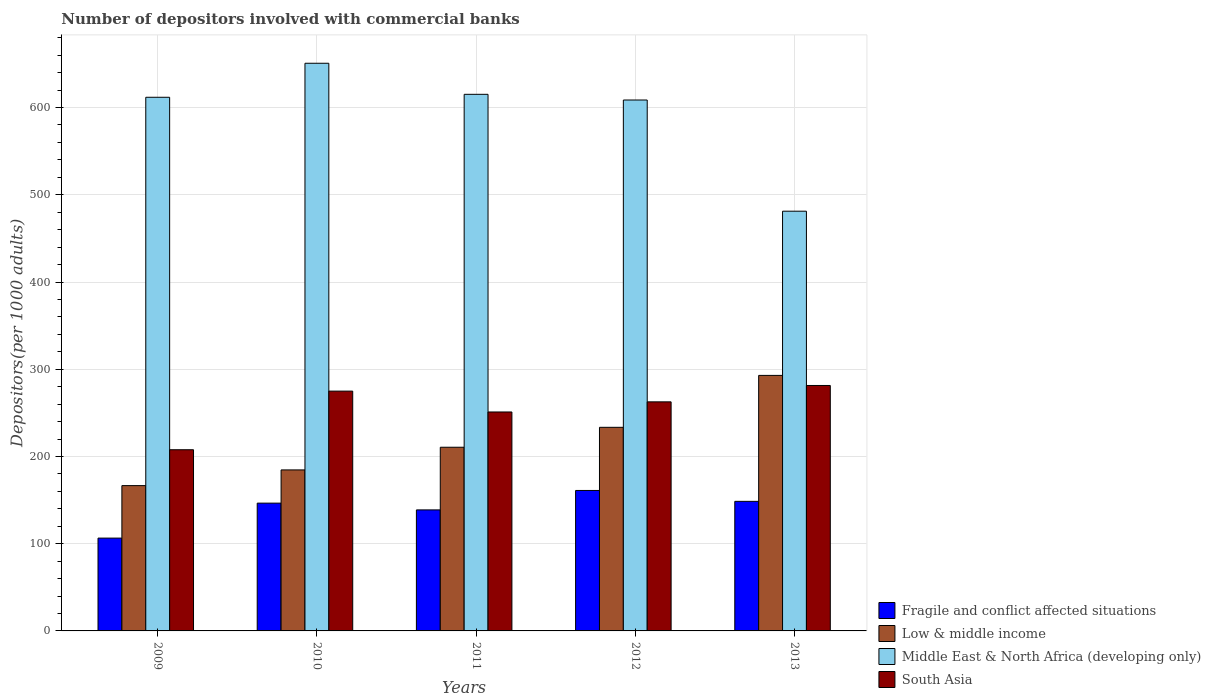How many groups of bars are there?
Offer a terse response. 5. Are the number of bars per tick equal to the number of legend labels?
Offer a very short reply. Yes. How many bars are there on the 2nd tick from the left?
Offer a terse response. 4. What is the label of the 1st group of bars from the left?
Give a very brief answer. 2009. In how many cases, is the number of bars for a given year not equal to the number of legend labels?
Give a very brief answer. 0. What is the number of depositors involved with commercial banks in Fragile and conflict affected situations in 2011?
Offer a terse response. 138.74. Across all years, what is the maximum number of depositors involved with commercial banks in South Asia?
Offer a terse response. 281.38. Across all years, what is the minimum number of depositors involved with commercial banks in Middle East & North Africa (developing only)?
Offer a terse response. 481.17. In which year was the number of depositors involved with commercial banks in South Asia minimum?
Provide a short and direct response. 2009. What is the total number of depositors involved with commercial banks in Low & middle income in the graph?
Your response must be concise. 1088.05. What is the difference between the number of depositors involved with commercial banks in Middle East & North Africa (developing only) in 2011 and that in 2013?
Offer a terse response. 133.99. What is the difference between the number of depositors involved with commercial banks in South Asia in 2010 and the number of depositors involved with commercial banks in Low & middle income in 2009?
Your answer should be compact. 108.34. What is the average number of depositors involved with commercial banks in Fragile and conflict affected situations per year?
Provide a short and direct response. 140.24. In the year 2009, what is the difference between the number of depositors involved with commercial banks in Fragile and conflict affected situations and number of depositors involved with commercial banks in Low & middle income?
Make the answer very short. -60.16. In how many years, is the number of depositors involved with commercial banks in South Asia greater than 560?
Provide a succinct answer. 0. What is the ratio of the number of depositors involved with commercial banks in Low & middle income in 2009 to that in 2012?
Your answer should be compact. 0.71. What is the difference between the highest and the second highest number of depositors involved with commercial banks in Low & middle income?
Your answer should be very brief. 59.52. What is the difference between the highest and the lowest number of depositors involved with commercial banks in Low & middle income?
Provide a succinct answer. 126.36. What does the 1st bar from the right in 2012 represents?
Provide a short and direct response. South Asia. Is it the case that in every year, the sum of the number of depositors involved with commercial banks in Low & middle income and number of depositors involved with commercial banks in South Asia is greater than the number of depositors involved with commercial banks in Middle East & North Africa (developing only)?
Your answer should be compact. No. Are all the bars in the graph horizontal?
Provide a succinct answer. No. What is the difference between two consecutive major ticks on the Y-axis?
Your answer should be compact. 100. Does the graph contain any zero values?
Your answer should be very brief. No. Where does the legend appear in the graph?
Ensure brevity in your answer.  Bottom right. How many legend labels are there?
Keep it short and to the point. 4. How are the legend labels stacked?
Offer a very short reply. Vertical. What is the title of the graph?
Ensure brevity in your answer.  Number of depositors involved with commercial banks. Does "Nigeria" appear as one of the legend labels in the graph?
Provide a succinct answer. No. What is the label or title of the X-axis?
Your answer should be compact. Years. What is the label or title of the Y-axis?
Offer a terse response. Depositors(per 1000 adults). What is the Depositors(per 1000 adults) of Fragile and conflict affected situations in 2009?
Your answer should be compact. 106.41. What is the Depositors(per 1000 adults) in Low & middle income in 2009?
Your response must be concise. 166.57. What is the Depositors(per 1000 adults) of Middle East & North Africa (developing only) in 2009?
Offer a terse response. 611.77. What is the Depositors(per 1000 adults) of South Asia in 2009?
Keep it short and to the point. 207.71. What is the Depositors(per 1000 adults) of Fragile and conflict affected situations in 2010?
Give a very brief answer. 146.5. What is the Depositors(per 1000 adults) of Low & middle income in 2010?
Offer a terse response. 184.58. What is the Depositors(per 1000 adults) of Middle East & North Africa (developing only) in 2010?
Provide a short and direct response. 650.77. What is the Depositors(per 1000 adults) of South Asia in 2010?
Ensure brevity in your answer.  274.9. What is the Depositors(per 1000 adults) in Fragile and conflict affected situations in 2011?
Your answer should be very brief. 138.74. What is the Depositors(per 1000 adults) in Low & middle income in 2011?
Your answer should be compact. 210.56. What is the Depositors(per 1000 adults) of Middle East & North Africa (developing only) in 2011?
Your response must be concise. 615.16. What is the Depositors(per 1000 adults) in South Asia in 2011?
Make the answer very short. 250.99. What is the Depositors(per 1000 adults) of Fragile and conflict affected situations in 2012?
Offer a very short reply. 161.02. What is the Depositors(per 1000 adults) of Low & middle income in 2012?
Provide a short and direct response. 233.41. What is the Depositors(per 1000 adults) of Middle East & North Africa (developing only) in 2012?
Ensure brevity in your answer.  608.64. What is the Depositors(per 1000 adults) of South Asia in 2012?
Give a very brief answer. 262.6. What is the Depositors(per 1000 adults) in Fragile and conflict affected situations in 2013?
Make the answer very short. 148.53. What is the Depositors(per 1000 adults) of Low & middle income in 2013?
Your answer should be compact. 292.93. What is the Depositors(per 1000 adults) in Middle East & North Africa (developing only) in 2013?
Keep it short and to the point. 481.17. What is the Depositors(per 1000 adults) in South Asia in 2013?
Your answer should be compact. 281.38. Across all years, what is the maximum Depositors(per 1000 adults) of Fragile and conflict affected situations?
Your response must be concise. 161.02. Across all years, what is the maximum Depositors(per 1000 adults) in Low & middle income?
Provide a short and direct response. 292.93. Across all years, what is the maximum Depositors(per 1000 adults) in Middle East & North Africa (developing only)?
Provide a short and direct response. 650.77. Across all years, what is the maximum Depositors(per 1000 adults) of South Asia?
Give a very brief answer. 281.38. Across all years, what is the minimum Depositors(per 1000 adults) of Fragile and conflict affected situations?
Provide a short and direct response. 106.41. Across all years, what is the minimum Depositors(per 1000 adults) of Low & middle income?
Give a very brief answer. 166.57. Across all years, what is the minimum Depositors(per 1000 adults) in Middle East & North Africa (developing only)?
Ensure brevity in your answer.  481.17. Across all years, what is the minimum Depositors(per 1000 adults) in South Asia?
Keep it short and to the point. 207.71. What is the total Depositors(per 1000 adults) in Fragile and conflict affected situations in the graph?
Provide a succinct answer. 701.2. What is the total Depositors(per 1000 adults) of Low & middle income in the graph?
Your response must be concise. 1088.05. What is the total Depositors(per 1000 adults) of Middle East & North Africa (developing only) in the graph?
Keep it short and to the point. 2967.5. What is the total Depositors(per 1000 adults) of South Asia in the graph?
Make the answer very short. 1277.59. What is the difference between the Depositors(per 1000 adults) in Fragile and conflict affected situations in 2009 and that in 2010?
Your response must be concise. -40.09. What is the difference between the Depositors(per 1000 adults) of Low & middle income in 2009 and that in 2010?
Give a very brief answer. -18.01. What is the difference between the Depositors(per 1000 adults) in Middle East & North Africa (developing only) in 2009 and that in 2010?
Offer a very short reply. -39. What is the difference between the Depositors(per 1000 adults) of South Asia in 2009 and that in 2010?
Make the answer very short. -67.19. What is the difference between the Depositors(per 1000 adults) of Fragile and conflict affected situations in 2009 and that in 2011?
Your answer should be very brief. -32.34. What is the difference between the Depositors(per 1000 adults) of Low & middle income in 2009 and that in 2011?
Make the answer very short. -43.99. What is the difference between the Depositors(per 1000 adults) in Middle East & North Africa (developing only) in 2009 and that in 2011?
Your answer should be compact. -3.39. What is the difference between the Depositors(per 1000 adults) of South Asia in 2009 and that in 2011?
Provide a short and direct response. -43.28. What is the difference between the Depositors(per 1000 adults) of Fragile and conflict affected situations in 2009 and that in 2012?
Offer a very short reply. -54.61. What is the difference between the Depositors(per 1000 adults) in Low & middle income in 2009 and that in 2012?
Your response must be concise. -66.84. What is the difference between the Depositors(per 1000 adults) in Middle East & North Africa (developing only) in 2009 and that in 2012?
Offer a terse response. 3.13. What is the difference between the Depositors(per 1000 adults) of South Asia in 2009 and that in 2012?
Give a very brief answer. -54.89. What is the difference between the Depositors(per 1000 adults) of Fragile and conflict affected situations in 2009 and that in 2013?
Make the answer very short. -42.13. What is the difference between the Depositors(per 1000 adults) in Low & middle income in 2009 and that in 2013?
Offer a very short reply. -126.36. What is the difference between the Depositors(per 1000 adults) in Middle East & North Africa (developing only) in 2009 and that in 2013?
Your answer should be compact. 130.6. What is the difference between the Depositors(per 1000 adults) in South Asia in 2009 and that in 2013?
Give a very brief answer. -73.67. What is the difference between the Depositors(per 1000 adults) of Fragile and conflict affected situations in 2010 and that in 2011?
Keep it short and to the point. 7.75. What is the difference between the Depositors(per 1000 adults) in Low & middle income in 2010 and that in 2011?
Offer a terse response. -25.98. What is the difference between the Depositors(per 1000 adults) of Middle East & North Africa (developing only) in 2010 and that in 2011?
Your answer should be very brief. 35.61. What is the difference between the Depositors(per 1000 adults) in South Asia in 2010 and that in 2011?
Provide a short and direct response. 23.91. What is the difference between the Depositors(per 1000 adults) in Fragile and conflict affected situations in 2010 and that in 2012?
Make the answer very short. -14.52. What is the difference between the Depositors(per 1000 adults) of Low & middle income in 2010 and that in 2012?
Your response must be concise. -48.83. What is the difference between the Depositors(per 1000 adults) in Middle East & North Africa (developing only) in 2010 and that in 2012?
Keep it short and to the point. 42.13. What is the difference between the Depositors(per 1000 adults) of South Asia in 2010 and that in 2012?
Make the answer very short. 12.31. What is the difference between the Depositors(per 1000 adults) in Fragile and conflict affected situations in 2010 and that in 2013?
Provide a short and direct response. -2.04. What is the difference between the Depositors(per 1000 adults) in Low & middle income in 2010 and that in 2013?
Your answer should be compact. -108.35. What is the difference between the Depositors(per 1000 adults) of Middle East & North Africa (developing only) in 2010 and that in 2013?
Give a very brief answer. 169.6. What is the difference between the Depositors(per 1000 adults) in South Asia in 2010 and that in 2013?
Make the answer very short. -6.48. What is the difference between the Depositors(per 1000 adults) in Fragile and conflict affected situations in 2011 and that in 2012?
Your response must be concise. -22.28. What is the difference between the Depositors(per 1000 adults) in Low & middle income in 2011 and that in 2012?
Offer a very short reply. -22.85. What is the difference between the Depositors(per 1000 adults) of Middle East & North Africa (developing only) in 2011 and that in 2012?
Provide a succinct answer. 6.52. What is the difference between the Depositors(per 1000 adults) in South Asia in 2011 and that in 2012?
Your response must be concise. -11.61. What is the difference between the Depositors(per 1000 adults) of Fragile and conflict affected situations in 2011 and that in 2013?
Offer a very short reply. -9.79. What is the difference between the Depositors(per 1000 adults) in Low & middle income in 2011 and that in 2013?
Your answer should be compact. -82.37. What is the difference between the Depositors(per 1000 adults) of Middle East & North Africa (developing only) in 2011 and that in 2013?
Make the answer very short. 133.99. What is the difference between the Depositors(per 1000 adults) of South Asia in 2011 and that in 2013?
Provide a short and direct response. -30.39. What is the difference between the Depositors(per 1000 adults) in Fragile and conflict affected situations in 2012 and that in 2013?
Provide a short and direct response. 12.49. What is the difference between the Depositors(per 1000 adults) in Low & middle income in 2012 and that in 2013?
Your answer should be compact. -59.52. What is the difference between the Depositors(per 1000 adults) in Middle East & North Africa (developing only) in 2012 and that in 2013?
Provide a succinct answer. 127.47. What is the difference between the Depositors(per 1000 adults) in South Asia in 2012 and that in 2013?
Ensure brevity in your answer.  -18.78. What is the difference between the Depositors(per 1000 adults) in Fragile and conflict affected situations in 2009 and the Depositors(per 1000 adults) in Low & middle income in 2010?
Your answer should be very brief. -78.17. What is the difference between the Depositors(per 1000 adults) of Fragile and conflict affected situations in 2009 and the Depositors(per 1000 adults) of Middle East & North Africa (developing only) in 2010?
Offer a terse response. -544.36. What is the difference between the Depositors(per 1000 adults) in Fragile and conflict affected situations in 2009 and the Depositors(per 1000 adults) in South Asia in 2010?
Keep it short and to the point. -168.5. What is the difference between the Depositors(per 1000 adults) in Low & middle income in 2009 and the Depositors(per 1000 adults) in Middle East & North Africa (developing only) in 2010?
Ensure brevity in your answer.  -484.2. What is the difference between the Depositors(per 1000 adults) of Low & middle income in 2009 and the Depositors(per 1000 adults) of South Asia in 2010?
Provide a succinct answer. -108.34. What is the difference between the Depositors(per 1000 adults) of Middle East & North Africa (developing only) in 2009 and the Depositors(per 1000 adults) of South Asia in 2010?
Make the answer very short. 336.86. What is the difference between the Depositors(per 1000 adults) of Fragile and conflict affected situations in 2009 and the Depositors(per 1000 adults) of Low & middle income in 2011?
Provide a short and direct response. -104.16. What is the difference between the Depositors(per 1000 adults) of Fragile and conflict affected situations in 2009 and the Depositors(per 1000 adults) of Middle East & North Africa (developing only) in 2011?
Offer a terse response. -508.75. What is the difference between the Depositors(per 1000 adults) in Fragile and conflict affected situations in 2009 and the Depositors(per 1000 adults) in South Asia in 2011?
Give a very brief answer. -144.59. What is the difference between the Depositors(per 1000 adults) of Low & middle income in 2009 and the Depositors(per 1000 adults) of Middle East & North Africa (developing only) in 2011?
Your response must be concise. -448.59. What is the difference between the Depositors(per 1000 adults) in Low & middle income in 2009 and the Depositors(per 1000 adults) in South Asia in 2011?
Your answer should be very brief. -84.42. What is the difference between the Depositors(per 1000 adults) in Middle East & North Africa (developing only) in 2009 and the Depositors(per 1000 adults) in South Asia in 2011?
Make the answer very short. 360.77. What is the difference between the Depositors(per 1000 adults) in Fragile and conflict affected situations in 2009 and the Depositors(per 1000 adults) in Low & middle income in 2012?
Make the answer very short. -127. What is the difference between the Depositors(per 1000 adults) in Fragile and conflict affected situations in 2009 and the Depositors(per 1000 adults) in Middle East & North Africa (developing only) in 2012?
Offer a terse response. -502.23. What is the difference between the Depositors(per 1000 adults) in Fragile and conflict affected situations in 2009 and the Depositors(per 1000 adults) in South Asia in 2012?
Provide a short and direct response. -156.19. What is the difference between the Depositors(per 1000 adults) in Low & middle income in 2009 and the Depositors(per 1000 adults) in Middle East & North Africa (developing only) in 2012?
Provide a succinct answer. -442.07. What is the difference between the Depositors(per 1000 adults) of Low & middle income in 2009 and the Depositors(per 1000 adults) of South Asia in 2012?
Provide a short and direct response. -96.03. What is the difference between the Depositors(per 1000 adults) of Middle East & North Africa (developing only) in 2009 and the Depositors(per 1000 adults) of South Asia in 2012?
Ensure brevity in your answer.  349.17. What is the difference between the Depositors(per 1000 adults) in Fragile and conflict affected situations in 2009 and the Depositors(per 1000 adults) in Low & middle income in 2013?
Keep it short and to the point. -186.52. What is the difference between the Depositors(per 1000 adults) of Fragile and conflict affected situations in 2009 and the Depositors(per 1000 adults) of Middle East & North Africa (developing only) in 2013?
Offer a terse response. -374.76. What is the difference between the Depositors(per 1000 adults) of Fragile and conflict affected situations in 2009 and the Depositors(per 1000 adults) of South Asia in 2013?
Offer a terse response. -174.97. What is the difference between the Depositors(per 1000 adults) in Low & middle income in 2009 and the Depositors(per 1000 adults) in Middle East & North Africa (developing only) in 2013?
Offer a very short reply. -314.6. What is the difference between the Depositors(per 1000 adults) of Low & middle income in 2009 and the Depositors(per 1000 adults) of South Asia in 2013?
Your response must be concise. -114.81. What is the difference between the Depositors(per 1000 adults) in Middle East & North Africa (developing only) in 2009 and the Depositors(per 1000 adults) in South Asia in 2013?
Offer a very short reply. 330.39. What is the difference between the Depositors(per 1000 adults) in Fragile and conflict affected situations in 2010 and the Depositors(per 1000 adults) in Low & middle income in 2011?
Make the answer very short. -64.07. What is the difference between the Depositors(per 1000 adults) in Fragile and conflict affected situations in 2010 and the Depositors(per 1000 adults) in Middle East & North Africa (developing only) in 2011?
Ensure brevity in your answer.  -468.66. What is the difference between the Depositors(per 1000 adults) in Fragile and conflict affected situations in 2010 and the Depositors(per 1000 adults) in South Asia in 2011?
Provide a short and direct response. -104.5. What is the difference between the Depositors(per 1000 adults) in Low & middle income in 2010 and the Depositors(per 1000 adults) in Middle East & North Africa (developing only) in 2011?
Your response must be concise. -430.58. What is the difference between the Depositors(per 1000 adults) in Low & middle income in 2010 and the Depositors(per 1000 adults) in South Asia in 2011?
Provide a short and direct response. -66.41. What is the difference between the Depositors(per 1000 adults) in Middle East & North Africa (developing only) in 2010 and the Depositors(per 1000 adults) in South Asia in 2011?
Your response must be concise. 399.77. What is the difference between the Depositors(per 1000 adults) of Fragile and conflict affected situations in 2010 and the Depositors(per 1000 adults) of Low & middle income in 2012?
Your answer should be compact. -86.91. What is the difference between the Depositors(per 1000 adults) in Fragile and conflict affected situations in 2010 and the Depositors(per 1000 adults) in Middle East & North Africa (developing only) in 2012?
Your answer should be compact. -462.14. What is the difference between the Depositors(per 1000 adults) in Fragile and conflict affected situations in 2010 and the Depositors(per 1000 adults) in South Asia in 2012?
Ensure brevity in your answer.  -116.1. What is the difference between the Depositors(per 1000 adults) in Low & middle income in 2010 and the Depositors(per 1000 adults) in Middle East & North Africa (developing only) in 2012?
Make the answer very short. -424.06. What is the difference between the Depositors(per 1000 adults) in Low & middle income in 2010 and the Depositors(per 1000 adults) in South Asia in 2012?
Keep it short and to the point. -78.02. What is the difference between the Depositors(per 1000 adults) of Middle East & North Africa (developing only) in 2010 and the Depositors(per 1000 adults) of South Asia in 2012?
Offer a very short reply. 388.17. What is the difference between the Depositors(per 1000 adults) of Fragile and conflict affected situations in 2010 and the Depositors(per 1000 adults) of Low & middle income in 2013?
Offer a very short reply. -146.43. What is the difference between the Depositors(per 1000 adults) of Fragile and conflict affected situations in 2010 and the Depositors(per 1000 adults) of Middle East & North Africa (developing only) in 2013?
Offer a very short reply. -334.67. What is the difference between the Depositors(per 1000 adults) of Fragile and conflict affected situations in 2010 and the Depositors(per 1000 adults) of South Asia in 2013?
Ensure brevity in your answer.  -134.88. What is the difference between the Depositors(per 1000 adults) in Low & middle income in 2010 and the Depositors(per 1000 adults) in Middle East & North Africa (developing only) in 2013?
Make the answer very short. -296.59. What is the difference between the Depositors(per 1000 adults) of Low & middle income in 2010 and the Depositors(per 1000 adults) of South Asia in 2013?
Keep it short and to the point. -96.8. What is the difference between the Depositors(per 1000 adults) in Middle East & North Africa (developing only) in 2010 and the Depositors(per 1000 adults) in South Asia in 2013?
Provide a short and direct response. 369.39. What is the difference between the Depositors(per 1000 adults) in Fragile and conflict affected situations in 2011 and the Depositors(per 1000 adults) in Low & middle income in 2012?
Your answer should be compact. -94.66. What is the difference between the Depositors(per 1000 adults) in Fragile and conflict affected situations in 2011 and the Depositors(per 1000 adults) in Middle East & North Africa (developing only) in 2012?
Your response must be concise. -469.9. What is the difference between the Depositors(per 1000 adults) in Fragile and conflict affected situations in 2011 and the Depositors(per 1000 adults) in South Asia in 2012?
Your answer should be compact. -123.86. What is the difference between the Depositors(per 1000 adults) in Low & middle income in 2011 and the Depositors(per 1000 adults) in Middle East & North Africa (developing only) in 2012?
Offer a very short reply. -398.08. What is the difference between the Depositors(per 1000 adults) of Low & middle income in 2011 and the Depositors(per 1000 adults) of South Asia in 2012?
Keep it short and to the point. -52.04. What is the difference between the Depositors(per 1000 adults) of Middle East & North Africa (developing only) in 2011 and the Depositors(per 1000 adults) of South Asia in 2012?
Keep it short and to the point. 352.56. What is the difference between the Depositors(per 1000 adults) of Fragile and conflict affected situations in 2011 and the Depositors(per 1000 adults) of Low & middle income in 2013?
Ensure brevity in your answer.  -154.19. What is the difference between the Depositors(per 1000 adults) of Fragile and conflict affected situations in 2011 and the Depositors(per 1000 adults) of Middle East & North Africa (developing only) in 2013?
Provide a succinct answer. -342.43. What is the difference between the Depositors(per 1000 adults) in Fragile and conflict affected situations in 2011 and the Depositors(per 1000 adults) in South Asia in 2013?
Your response must be concise. -142.64. What is the difference between the Depositors(per 1000 adults) in Low & middle income in 2011 and the Depositors(per 1000 adults) in Middle East & North Africa (developing only) in 2013?
Ensure brevity in your answer.  -270.61. What is the difference between the Depositors(per 1000 adults) of Low & middle income in 2011 and the Depositors(per 1000 adults) of South Asia in 2013?
Make the answer very short. -70.82. What is the difference between the Depositors(per 1000 adults) of Middle East & North Africa (developing only) in 2011 and the Depositors(per 1000 adults) of South Asia in 2013?
Your answer should be very brief. 333.78. What is the difference between the Depositors(per 1000 adults) in Fragile and conflict affected situations in 2012 and the Depositors(per 1000 adults) in Low & middle income in 2013?
Offer a terse response. -131.91. What is the difference between the Depositors(per 1000 adults) in Fragile and conflict affected situations in 2012 and the Depositors(per 1000 adults) in Middle East & North Africa (developing only) in 2013?
Provide a succinct answer. -320.15. What is the difference between the Depositors(per 1000 adults) in Fragile and conflict affected situations in 2012 and the Depositors(per 1000 adults) in South Asia in 2013?
Provide a short and direct response. -120.36. What is the difference between the Depositors(per 1000 adults) in Low & middle income in 2012 and the Depositors(per 1000 adults) in Middle East & North Africa (developing only) in 2013?
Make the answer very short. -247.76. What is the difference between the Depositors(per 1000 adults) in Low & middle income in 2012 and the Depositors(per 1000 adults) in South Asia in 2013?
Keep it short and to the point. -47.97. What is the difference between the Depositors(per 1000 adults) of Middle East & North Africa (developing only) in 2012 and the Depositors(per 1000 adults) of South Asia in 2013?
Offer a very short reply. 327.26. What is the average Depositors(per 1000 adults) in Fragile and conflict affected situations per year?
Your answer should be very brief. 140.24. What is the average Depositors(per 1000 adults) of Low & middle income per year?
Offer a very short reply. 217.61. What is the average Depositors(per 1000 adults) in Middle East & North Africa (developing only) per year?
Give a very brief answer. 593.5. What is the average Depositors(per 1000 adults) of South Asia per year?
Offer a terse response. 255.52. In the year 2009, what is the difference between the Depositors(per 1000 adults) in Fragile and conflict affected situations and Depositors(per 1000 adults) in Low & middle income?
Offer a very short reply. -60.16. In the year 2009, what is the difference between the Depositors(per 1000 adults) in Fragile and conflict affected situations and Depositors(per 1000 adults) in Middle East & North Africa (developing only)?
Give a very brief answer. -505.36. In the year 2009, what is the difference between the Depositors(per 1000 adults) of Fragile and conflict affected situations and Depositors(per 1000 adults) of South Asia?
Your answer should be compact. -101.3. In the year 2009, what is the difference between the Depositors(per 1000 adults) in Low & middle income and Depositors(per 1000 adults) in Middle East & North Africa (developing only)?
Provide a succinct answer. -445.2. In the year 2009, what is the difference between the Depositors(per 1000 adults) in Low & middle income and Depositors(per 1000 adults) in South Asia?
Ensure brevity in your answer.  -41.14. In the year 2009, what is the difference between the Depositors(per 1000 adults) of Middle East & North Africa (developing only) and Depositors(per 1000 adults) of South Asia?
Keep it short and to the point. 404.05. In the year 2010, what is the difference between the Depositors(per 1000 adults) in Fragile and conflict affected situations and Depositors(per 1000 adults) in Low & middle income?
Your answer should be very brief. -38.08. In the year 2010, what is the difference between the Depositors(per 1000 adults) in Fragile and conflict affected situations and Depositors(per 1000 adults) in Middle East & North Africa (developing only)?
Provide a succinct answer. -504.27. In the year 2010, what is the difference between the Depositors(per 1000 adults) of Fragile and conflict affected situations and Depositors(per 1000 adults) of South Asia?
Provide a short and direct response. -128.41. In the year 2010, what is the difference between the Depositors(per 1000 adults) of Low & middle income and Depositors(per 1000 adults) of Middle East & North Africa (developing only)?
Make the answer very short. -466.19. In the year 2010, what is the difference between the Depositors(per 1000 adults) in Low & middle income and Depositors(per 1000 adults) in South Asia?
Your response must be concise. -90.32. In the year 2010, what is the difference between the Depositors(per 1000 adults) of Middle East & North Africa (developing only) and Depositors(per 1000 adults) of South Asia?
Ensure brevity in your answer.  375.86. In the year 2011, what is the difference between the Depositors(per 1000 adults) of Fragile and conflict affected situations and Depositors(per 1000 adults) of Low & middle income?
Offer a very short reply. -71.82. In the year 2011, what is the difference between the Depositors(per 1000 adults) in Fragile and conflict affected situations and Depositors(per 1000 adults) in Middle East & North Africa (developing only)?
Offer a very short reply. -476.41. In the year 2011, what is the difference between the Depositors(per 1000 adults) of Fragile and conflict affected situations and Depositors(per 1000 adults) of South Asia?
Provide a succinct answer. -112.25. In the year 2011, what is the difference between the Depositors(per 1000 adults) in Low & middle income and Depositors(per 1000 adults) in Middle East & North Africa (developing only)?
Your response must be concise. -404.6. In the year 2011, what is the difference between the Depositors(per 1000 adults) in Low & middle income and Depositors(per 1000 adults) in South Asia?
Keep it short and to the point. -40.43. In the year 2011, what is the difference between the Depositors(per 1000 adults) of Middle East & North Africa (developing only) and Depositors(per 1000 adults) of South Asia?
Your answer should be very brief. 364.16. In the year 2012, what is the difference between the Depositors(per 1000 adults) of Fragile and conflict affected situations and Depositors(per 1000 adults) of Low & middle income?
Offer a terse response. -72.39. In the year 2012, what is the difference between the Depositors(per 1000 adults) of Fragile and conflict affected situations and Depositors(per 1000 adults) of Middle East & North Africa (developing only)?
Offer a very short reply. -447.62. In the year 2012, what is the difference between the Depositors(per 1000 adults) of Fragile and conflict affected situations and Depositors(per 1000 adults) of South Asia?
Offer a very short reply. -101.58. In the year 2012, what is the difference between the Depositors(per 1000 adults) of Low & middle income and Depositors(per 1000 adults) of Middle East & North Africa (developing only)?
Your answer should be compact. -375.23. In the year 2012, what is the difference between the Depositors(per 1000 adults) in Low & middle income and Depositors(per 1000 adults) in South Asia?
Keep it short and to the point. -29.19. In the year 2012, what is the difference between the Depositors(per 1000 adults) in Middle East & North Africa (developing only) and Depositors(per 1000 adults) in South Asia?
Keep it short and to the point. 346.04. In the year 2013, what is the difference between the Depositors(per 1000 adults) of Fragile and conflict affected situations and Depositors(per 1000 adults) of Low & middle income?
Your answer should be very brief. -144.4. In the year 2013, what is the difference between the Depositors(per 1000 adults) in Fragile and conflict affected situations and Depositors(per 1000 adults) in Middle East & North Africa (developing only)?
Provide a succinct answer. -332.64. In the year 2013, what is the difference between the Depositors(per 1000 adults) of Fragile and conflict affected situations and Depositors(per 1000 adults) of South Asia?
Offer a terse response. -132.85. In the year 2013, what is the difference between the Depositors(per 1000 adults) of Low & middle income and Depositors(per 1000 adults) of Middle East & North Africa (developing only)?
Offer a very short reply. -188.24. In the year 2013, what is the difference between the Depositors(per 1000 adults) in Low & middle income and Depositors(per 1000 adults) in South Asia?
Provide a short and direct response. 11.55. In the year 2013, what is the difference between the Depositors(per 1000 adults) in Middle East & North Africa (developing only) and Depositors(per 1000 adults) in South Asia?
Ensure brevity in your answer.  199.79. What is the ratio of the Depositors(per 1000 adults) in Fragile and conflict affected situations in 2009 to that in 2010?
Your answer should be compact. 0.73. What is the ratio of the Depositors(per 1000 adults) of Low & middle income in 2009 to that in 2010?
Your response must be concise. 0.9. What is the ratio of the Depositors(per 1000 adults) of Middle East & North Africa (developing only) in 2009 to that in 2010?
Give a very brief answer. 0.94. What is the ratio of the Depositors(per 1000 adults) in South Asia in 2009 to that in 2010?
Ensure brevity in your answer.  0.76. What is the ratio of the Depositors(per 1000 adults) in Fragile and conflict affected situations in 2009 to that in 2011?
Your answer should be compact. 0.77. What is the ratio of the Depositors(per 1000 adults) in Low & middle income in 2009 to that in 2011?
Keep it short and to the point. 0.79. What is the ratio of the Depositors(per 1000 adults) in Middle East & North Africa (developing only) in 2009 to that in 2011?
Provide a short and direct response. 0.99. What is the ratio of the Depositors(per 1000 adults) of South Asia in 2009 to that in 2011?
Your answer should be compact. 0.83. What is the ratio of the Depositors(per 1000 adults) of Fragile and conflict affected situations in 2009 to that in 2012?
Provide a short and direct response. 0.66. What is the ratio of the Depositors(per 1000 adults) of Low & middle income in 2009 to that in 2012?
Keep it short and to the point. 0.71. What is the ratio of the Depositors(per 1000 adults) in Middle East & North Africa (developing only) in 2009 to that in 2012?
Provide a short and direct response. 1.01. What is the ratio of the Depositors(per 1000 adults) of South Asia in 2009 to that in 2012?
Ensure brevity in your answer.  0.79. What is the ratio of the Depositors(per 1000 adults) of Fragile and conflict affected situations in 2009 to that in 2013?
Your answer should be compact. 0.72. What is the ratio of the Depositors(per 1000 adults) in Low & middle income in 2009 to that in 2013?
Keep it short and to the point. 0.57. What is the ratio of the Depositors(per 1000 adults) in Middle East & North Africa (developing only) in 2009 to that in 2013?
Keep it short and to the point. 1.27. What is the ratio of the Depositors(per 1000 adults) in South Asia in 2009 to that in 2013?
Offer a very short reply. 0.74. What is the ratio of the Depositors(per 1000 adults) of Fragile and conflict affected situations in 2010 to that in 2011?
Provide a succinct answer. 1.06. What is the ratio of the Depositors(per 1000 adults) of Low & middle income in 2010 to that in 2011?
Provide a short and direct response. 0.88. What is the ratio of the Depositors(per 1000 adults) of Middle East & North Africa (developing only) in 2010 to that in 2011?
Offer a very short reply. 1.06. What is the ratio of the Depositors(per 1000 adults) in South Asia in 2010 to that in 2011?
Make the answer very short. 1.1. What is the ratio of the Depositors(per 1000 adults) of Fragile and conflict affected situations in 2010 to that in 2012?
Make the answer very short. 0.91. What is the ratio of the Depositors(per 1000 adults) of Low & middle income in 2010 to that in 2012?
Your answer should be compact. 0.79. What is the ratio of the Depositors(per 1000 adults) in Middle East & North Africa (developing only) in 2010 to that in 2012?
Your answer should be very brief. 1.07. What is the ratio of the Depositors(per 1000 adults) in South Asia in 2010 to that in 2012?
Your answer should be compact. 1.05. What is the ratio of the Depositors(per 1000 adults) of Fragile and conflict affected situations in 2010 to that in 2013?
Your answer should be very brief. 0.99. What is the ratio of the Depositors(per 1000 adults) in Low & middle income in 2010 to that in 2013?
Make the answer very short. 0.63. What is the ratio of the Depositors(per 1000 adults) of Middle East & North Africa (developing only) in 2010 to that in 2013?
Provide a succinct answer. 1.35. What is the ratio of the Depositors(per 1000 adults) in Fragile and conflict affected situations in 2011 to that in 2012?
Your answer should be compact. 0.86. What is the ratio of the Depositors(per 1000 adults) of Low & middle income in 2011 to that in 2012?
Ensure brevity in your answer.  0.9. What is the ratio of the Depositors(per 1000 adults) of Middle East & North Africa (developing only) in 2011 to that in 2012?
Provide a short and direct response. 1.01. What is the ratio of the Depositors(per 1000 adults) of South Asia in 2011 to that in 2012?
Your answer should be very brief. 0.96. What is the ratio of the Depositors(per 1000 adults) in Fragile and conflict affected situations in 2011 to that in 2013?
Make the answer very short. 0.93. What is the ratio of the Depositors(per 1000 adults) in Low & middle income in 2011 to that in 2013?
Make the answer very short. 0.72. What is the ratio of the Depositors(per 1000 adults) in Middle East & North Africa (developing only) in 2011 to that in 2013?
Provide a succinct answer. 1.28. What is the ratio of the Depositors(per 1000 adults) in South Asia in 2011 to that in 2013?
Your answer should be compact. 0.89. What is the ratio of the Depositors(per 1000 adults) in Fragile and conflict affected situations in 2012 to that in 2013?
Keep it short and to the point. 1.08. What is the ratio of the Depositors(per 1000 adults) of Low & middle income in 2012 to that in 2013?
Give a very brief answer. 0.8. What is the ratio of the Depositors(per 1000 adults) in Middle East & North Africa (developing only) in 2012 to that in 2013?
Provide a succinct answer. 1.26. What is the difference between the highest and the second highest Depositors(per 1000 adults) of Fragile and conflict affected situations?
Ensure brevity in your answer.  12.49. What is the difference between the highest and the second highest Depositors(per 1000 adults) in Low & middle income?
Your response must be concise. 59.52. What is the difference between the highest and the second highest Depositors(per 1000 adults) of Middle East & North Africa (developing only)?
Give a very brief answer. 35.61. What is the difference between the highest and the second highest Depositors(per 1000 adults) in South Asia?
Ensure brevity in your answer.  6.48. What is the difference between the highest and the lowest Depositors(per 1000 adults) of Fragile and conflict affected situations?
Offer a very short reply. 54.61. What is the difference between the highest and the lowest Depositors(per 1000 adults) in Low & middle income?
Your answer should be compact. 126.36. What is the difference between the highest and the lowest Depositors(per 1000 adults) in Middle East & North Africa (developing only)?
Keep it short and to the point. 169.6. What is the difference between the highest and the lowest Depositors(per 1000 adults) in South Asia?
Make the answer very short. 73.67. 